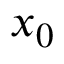Convert formula to latex. <formula><loc_0><loc_0><loc_500><loc_500>x _ { 0 }</formula> 